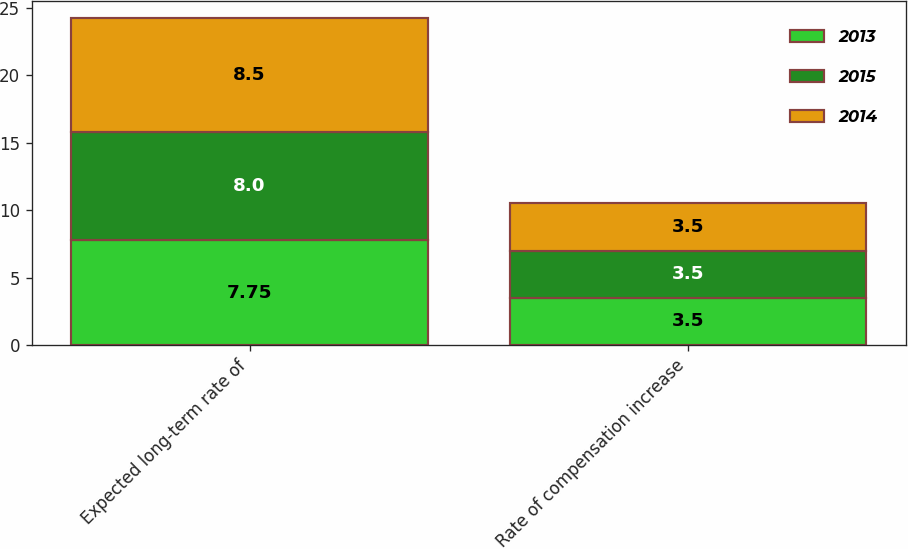<chart> <loc_0><loc_0><loc_500><loc_500><stacked_bar_chart><ecel><fcel>Expected long-term rate of<fcel>Rate of compensation increase<nl><fcel>2013<fcel>7.75<fcel>3.5<nl><fcel>2015<fcel>8<fcel>3.5<nl><fcel>2014<fcel>8.5<fcel>3.5<nl></chart> 